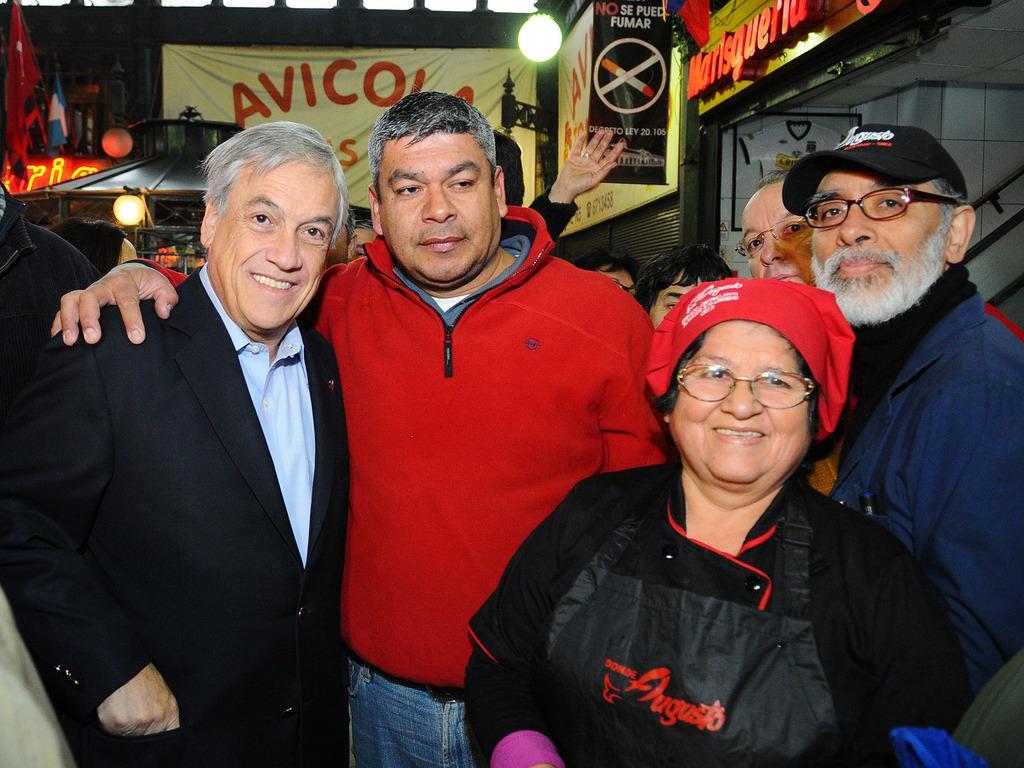Can you describe this image briefly? In the center of the image there are people standing. In the background of the image there are banners. There is a light. There is wall. 